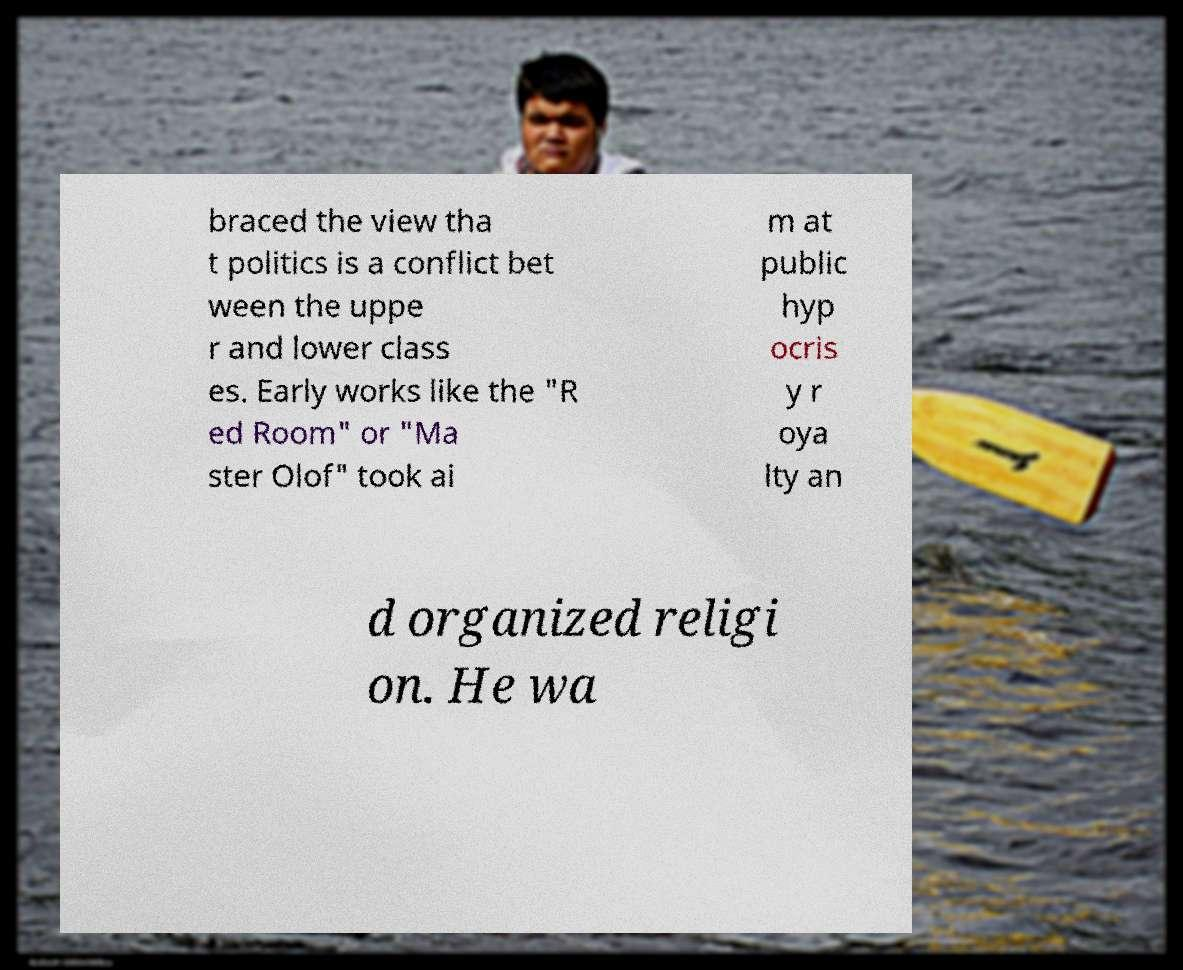For documentation purposes, I need the text within this image transcribed. Could you provide that? braced the view tha t politics is a conflict bet ween the uppe r and lower class es. Early works like the "R ed Room" or "Ma ster Olof" took ai m at public hyp ocris y r oya lty an d organized religi on. He wa 